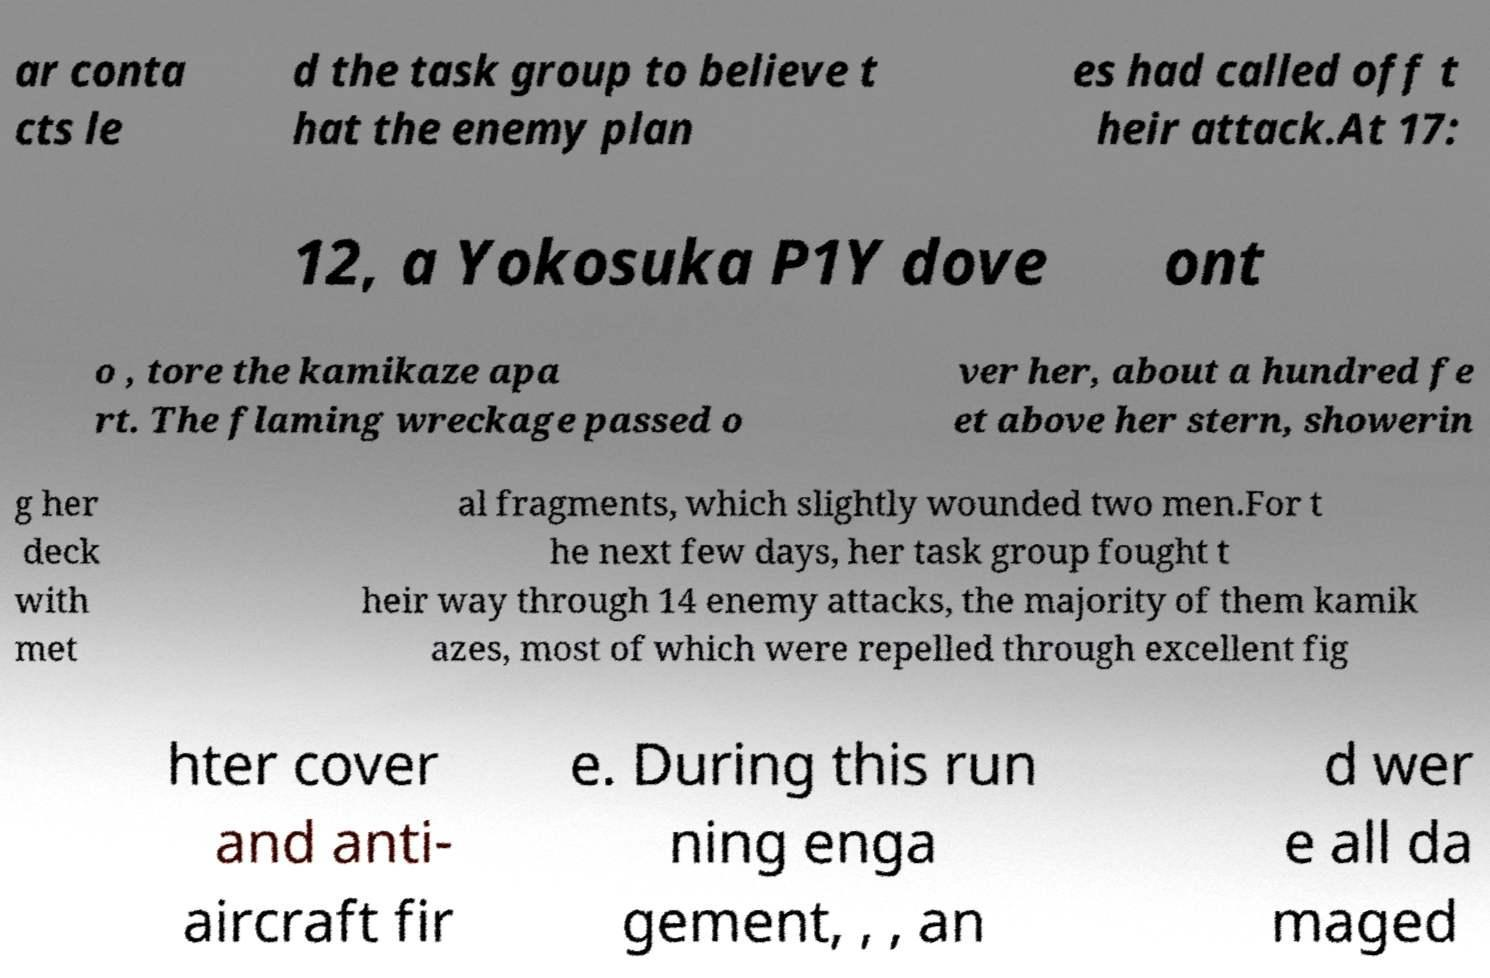Can you read and provide the text displayed in the image?This photo seems to have some interesting text. Can you extract and type it out for me? ar conta cts le d the task group to believe t hat the enemy plan es had called off t heir attack.At 17: 12, a Yokosuka P1Y dove ont o , tore the kamikaze apa rt. The flaming wreckage passed o ver her, about a hundred fe et above her stern, showerin g her deck with met al fragments, which slightly wounded two men.For t he next few days, her task group fought t heir way through 14 enemy attacks, the majority of them kamik azes, most of which were repelled through excellent fig hter cover and anti- aircraft fir e. During this run ning enga gement, , , an d wer e all da maged 